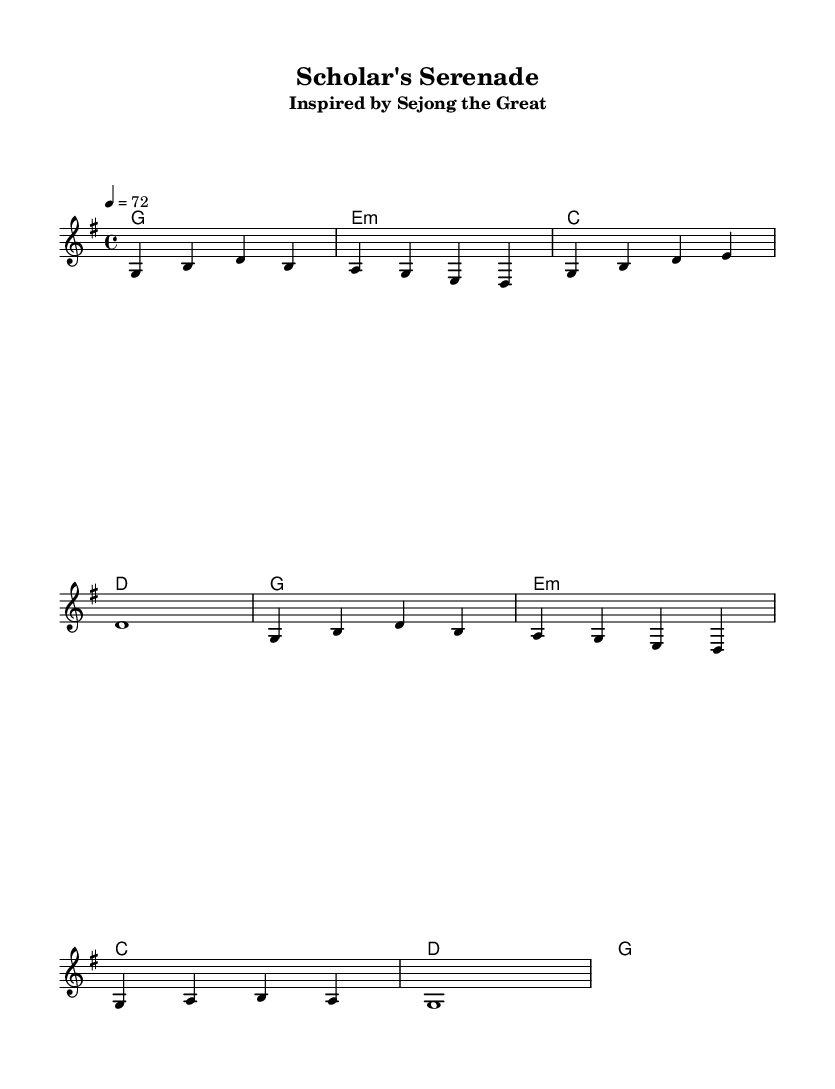What is the key signature of this music? The key signature is G major, which is indicated by one sharp (F#) in the music sheet.
Answer: G major What is the time signature of this music? The time signature is 4/4, which means there are four beats in a measure and the quarter note gets one beat, indicated at the beginning of the sheet music.
Answer: 4/4 What is the tempo marking for this piece? The tempo marking is 72 beats per minute, as indicated in the sheet music, serving as a measure of speed for the performance.
Answer: 72 How many measures are in the melody section? The melody section consists of four measures that are clearly delineated in the music sheet. Each measure is separated by vertical lines.
Answer: Four What is the primary chord used in the harmony? The primary chord used in the harmony throughout the piece is G major, as indicated in the chord names section and is the first chord of the progression.
Answer: G What historical figure inspires this K-Pop album? The historical figure that inspires this K-Pop album is Sejong the Great, as stated in the subtitle of the score.
Answer: Sejong the Great What type of musical mode is utilized in this composition? The musical mode utilized in this composition is a chord mode, specifically indicated by the use of harmonies which incorporates various chord progressions throughout the piece.
Answer: Chord mode 